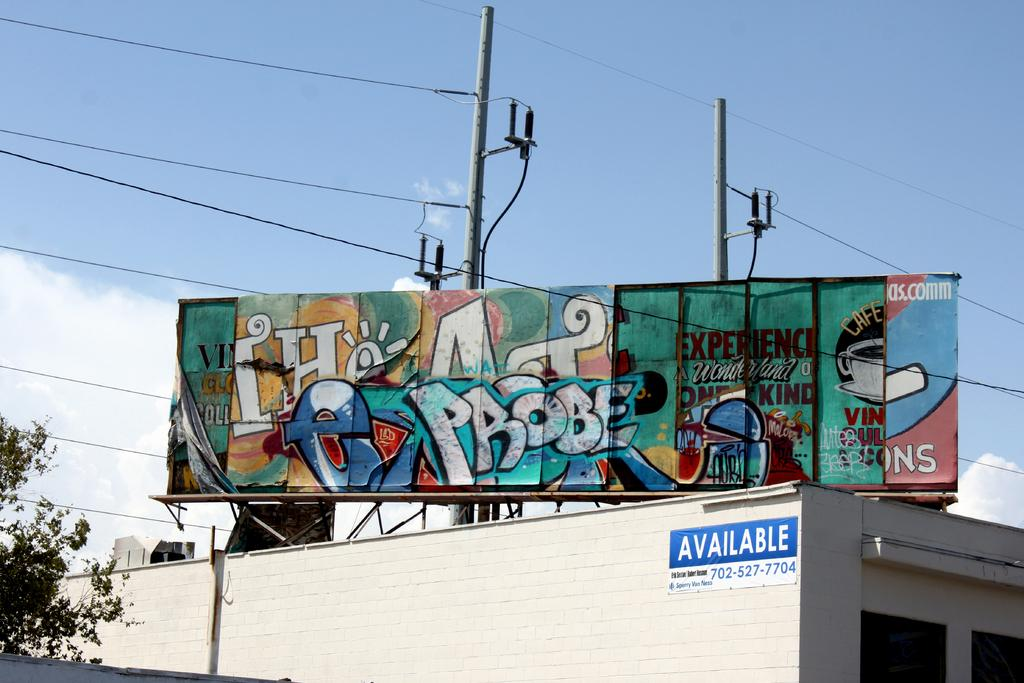<image>
Describe the image concisely. A colorful graffiti billboard sits above an available building. 